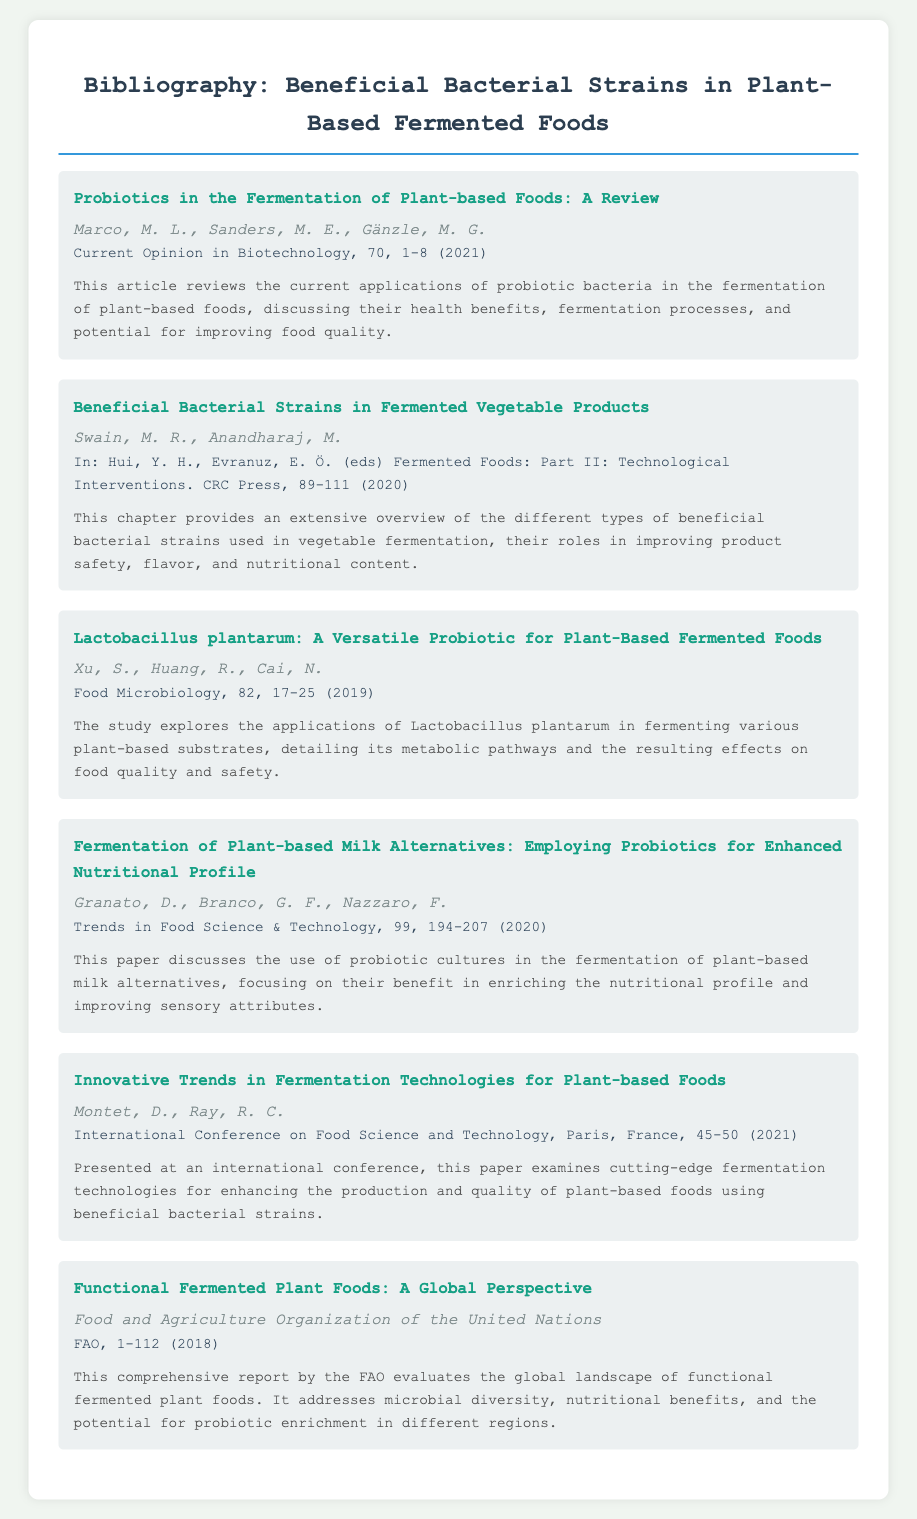What is the title of the first entry? The title of the first entry is the main heading given to it in the document, which is "Probiotics in the Fermentation of Plant-based Foods: A Review."
Answer: Probiotics in the Fermentation of Plant-based Foods: A Review Who are the authors of the article discussing Lactobacillus plantarum? The authors' names are listed directly below the title of the entry on Lactobacillus plantarum, which are Xu, S., Huang, R., Cai, N.
Answer: Xu, S., Huang, R., Cai, N In which journal was the paper on plant-based milk alternatives published? The journal in which the related entry is published is indicated in the details section for that entry, which states "Trends in Food Science & Technology."
Answer: Trends in Food Science & Technology What year was the FAO report on functional fermented plant foods released? The year of release is included in the details of the entry by the FAO, which indicates it was published in 2018.
Answer: 2018 What is the main focus of the article by Granato et al.? The summary provided for the article outlines its main focus, which is the use of probiotic cultures in plant-based milk alternatives.
Answer: Probiotic cultures in plant-based milk alternatives What type of document is presented in this bibliography? The document presents a collection of academic references, typically organized by topic and provides specific details about each source.
Answer: Bibliography Which bacterial strain is frequently discussed in relation to plant-based foods according to the entries? The strain mentioned specifically in multiple entries related to plant-based foods is indicated throughout the document.
Answer: Lactobacillus plantarum 